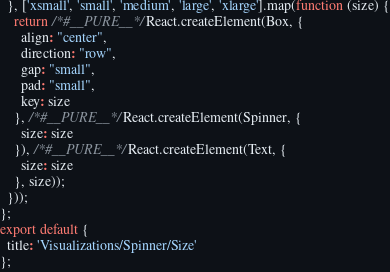<code> <loc_0><loc_0><loc_500><loc_500><_JavaScript_>  }, ['xsmall', 'small', 'medium', 'large', 'xlarge'].map(function (size) {
    return /*#__PURE__*/React.createElement(Box, {
      align: "center",
      direction: "row",
      gap: "small",
      pad: "small",
      key: size
    }, /*#__PURE__*/React.createElement(Spinner, {
      size: size
    }), /*#__PURE__*/React.createElement(Text, {
      size: size
    }, size));
  }));
};
export default {
  title: 'Visualizations/Spinner/Size'
};</code> 